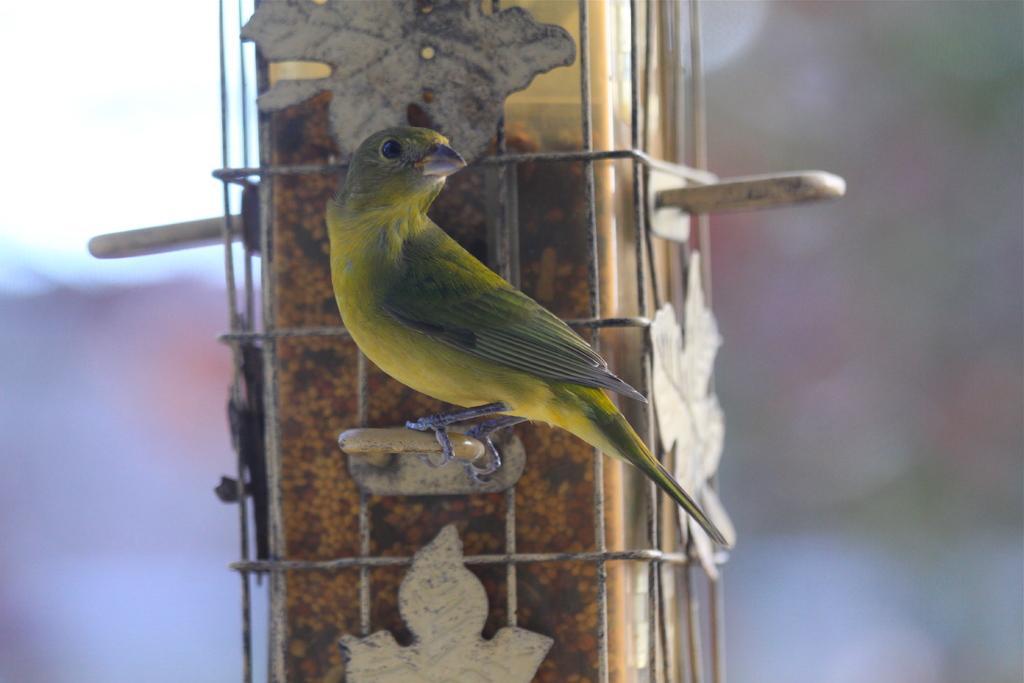Could you give a brief overview of what you see in this image? In this picture there is a bunting bird, standing on this stick. Beside that we can see pillar. On the top left corner there is a sky. 